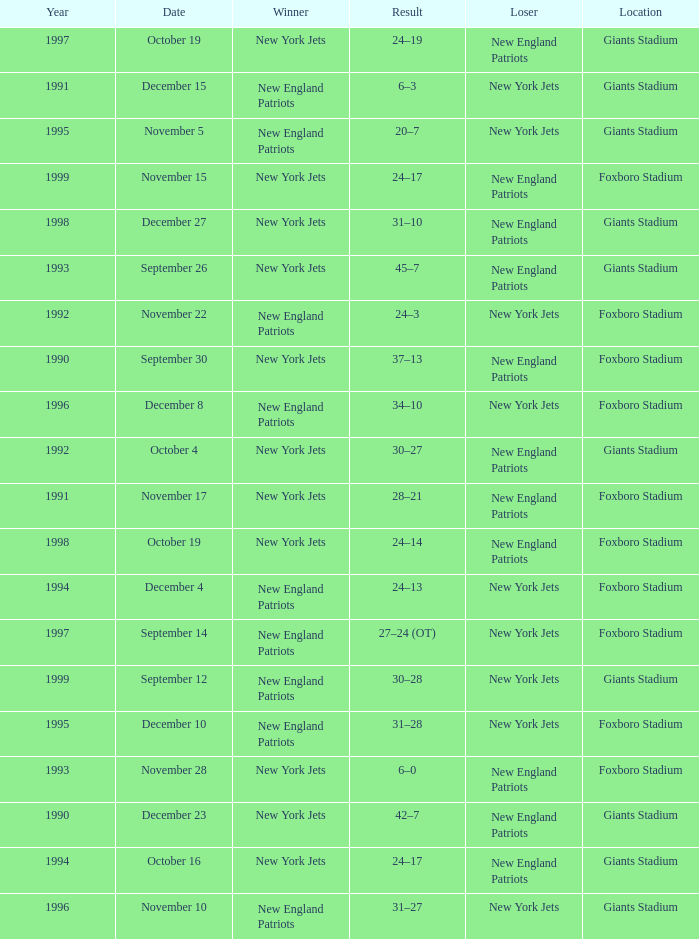What team was the lower when the winner was the new york jets, and a Year earlier than 1994, and a Result of 37–13? New England Patriots. 